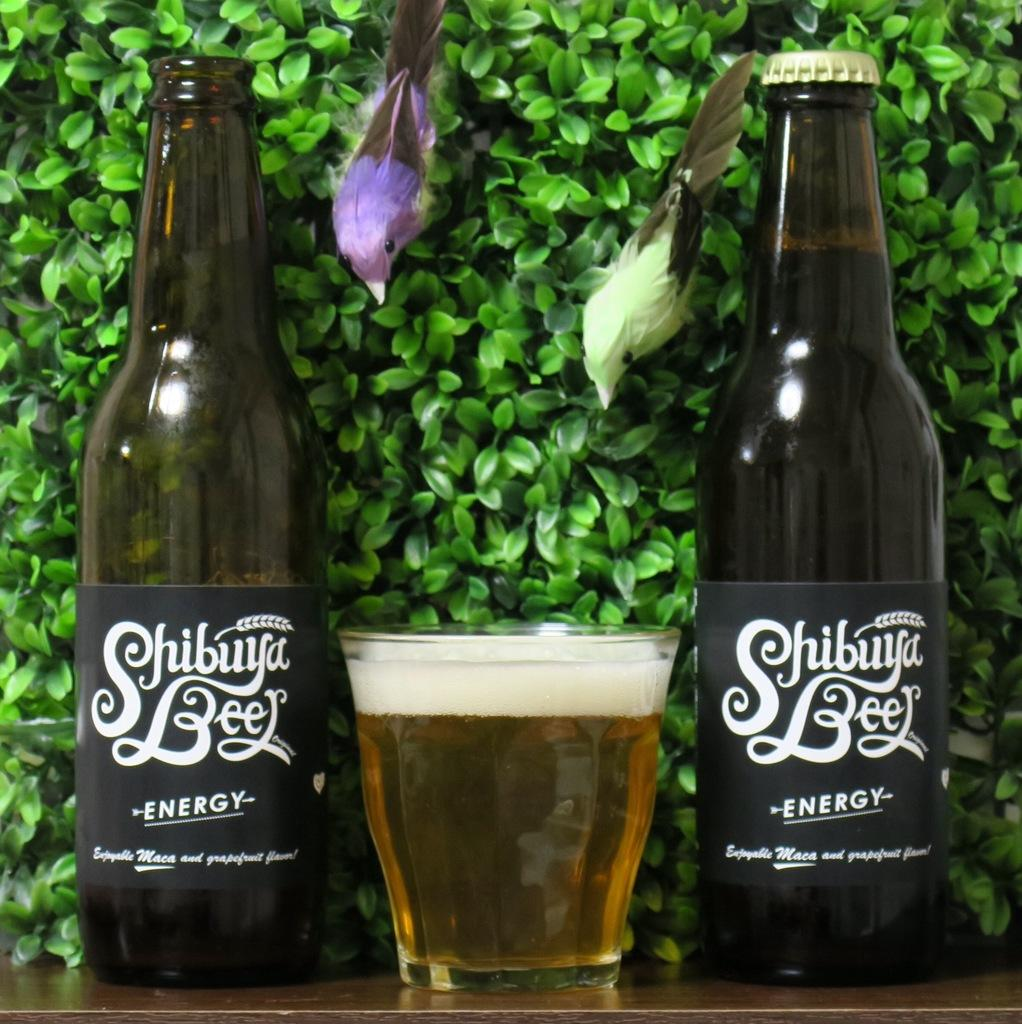Provide a one-sentence caption for the provided image. Two Shibuya Energy Beers with a full glass of beer in between the two beers. 